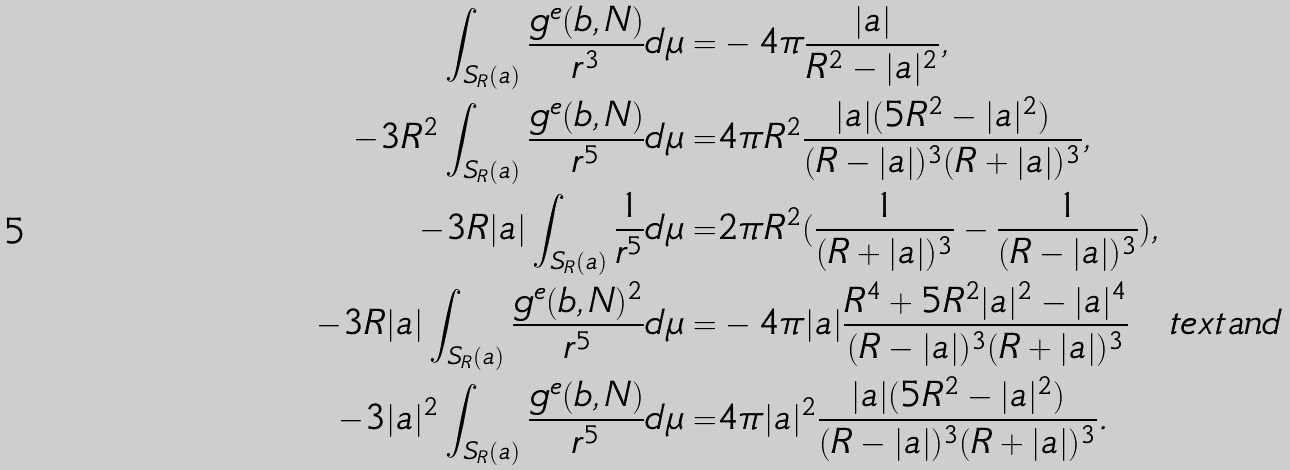Convert formula to latex. <formula><loc_0><loc_0><loc_500><loc_500>\int _ { S _ { R } ( a ) } \frac { g ^ { e } ( b , N ) } { r ^ { 3 } } d \mu = & - 4 \pi \frac { | a | } { R ^ { 2 } - | a | ^ { 2 } } , \\ - 3 R ^ { 2 } \int _ { S _ { R } ( a ) } \frac { g ^ { e } ( b , N ) } { r ^ { 5 } } d \mu = & 4 \pi R ^ { 2 } \frac { | a | ( 5 R ^ { 2 } - | a | ^ { 2 } ) } { ( R - | a | ) ^ { 3 } ( R + | a | ) ^ { 3 } } , \\ - 3 R | a | \int _ { S _ { R } ( a ) } \frac { 1 } { r ^ { 5 } } d \mu = & 2 \pi R ^ { 2 } ( \frac { 1 } { ( R + | a | ) ^ { 3 } } - \frac { 1 } { ( R - | a | ) ^ { 3 } } ) , \\ - 3 R | a | \int _ { S _ { R } ( a ) } \frac { g ^ { e } ( b , N ) ^ { 2 } } { r ^ { 5 } } d \mu = & - 4 \pi | a | \frac { R ^ { 4 } + 5 R ^ { 2 } | a | ^ { 2 } - | a | ^ { 4 } } { ( R - | a | ) ^ { 3 } ( R + | a | ) ^ { 3 } } \quad t e x t { a n d } \\ - 3 | a | ^ { 2 } \int _ { S _ { R } ( a ) } \frac { g ^ { e } ( b , N ) } { r ^ { 5 } } d \mu = & 4 \pi | a | ^ { 2 } \frac { | a | ( 5 R ^ { 2 } - | a | ^ { 2 } ) } { ( R - | a | ) ^ { 3 } ( R + | a | ) ^ { 3 } } .</formula> 